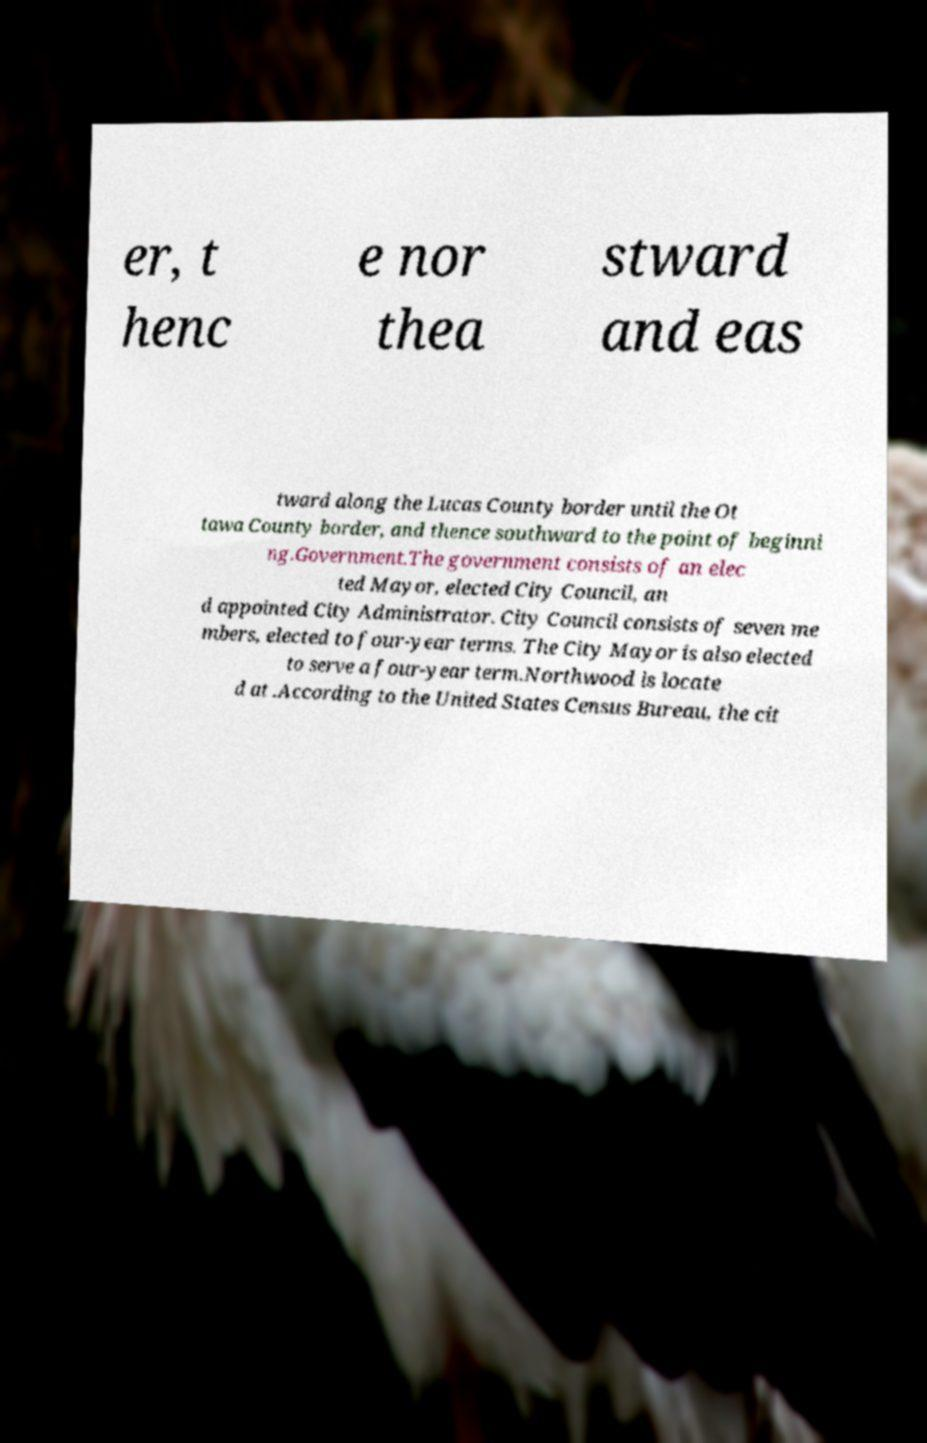Can you read and provide the text displayed in the image?This photo seems to have some interesting text. Can you extract and type it out for me? er, t henc e nor thea stward and eas tward along the Lucas County border until the Ot tawa County border, and thence southward to the point of beginni ng.Government.The government consists of an elec ted Mayor, elected City Council, an d appointed City Administrator. City Council consists of seven me mbers, elected to four-year terms. The City Mayor is also elected to serve a four-year term.Northwood is locate d at .According to the United States Census Bureau, the cit 